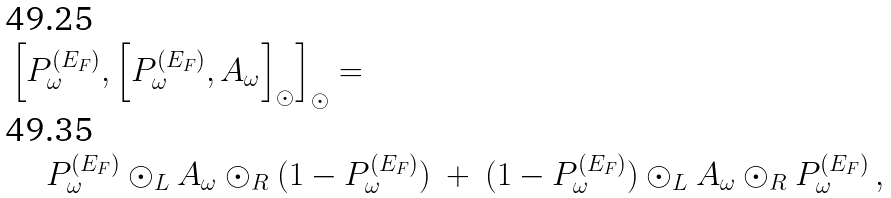Convert formula to latex. <formula><loc_0><loc_0><loc_500><loc_500>& \left [ P ^ { ( E _ { F } ) } _ { \omega } , \left [ P ^ { ( E _ { F } ) } _ { \omega } , A _ { \omega } \right ] _ { \odot } \right ] _ { \odot } = \\ & \quad \ P ^ { ( E _ { F } ) } _ { \omega } \odot _ { L } A _ { \omega } \odot _ { R } ( 1 - P ^ { ( E _ { F } ) } _ { \omega } ) \ + \ ( 1 - P ^ { ( E _ { F } ) } _ { \omega } ) \odot _ { L } A _ { \omega } \odot _ { R } P ^ { ( E _ { F } ) } _ { \omega } \, ,</formula> 